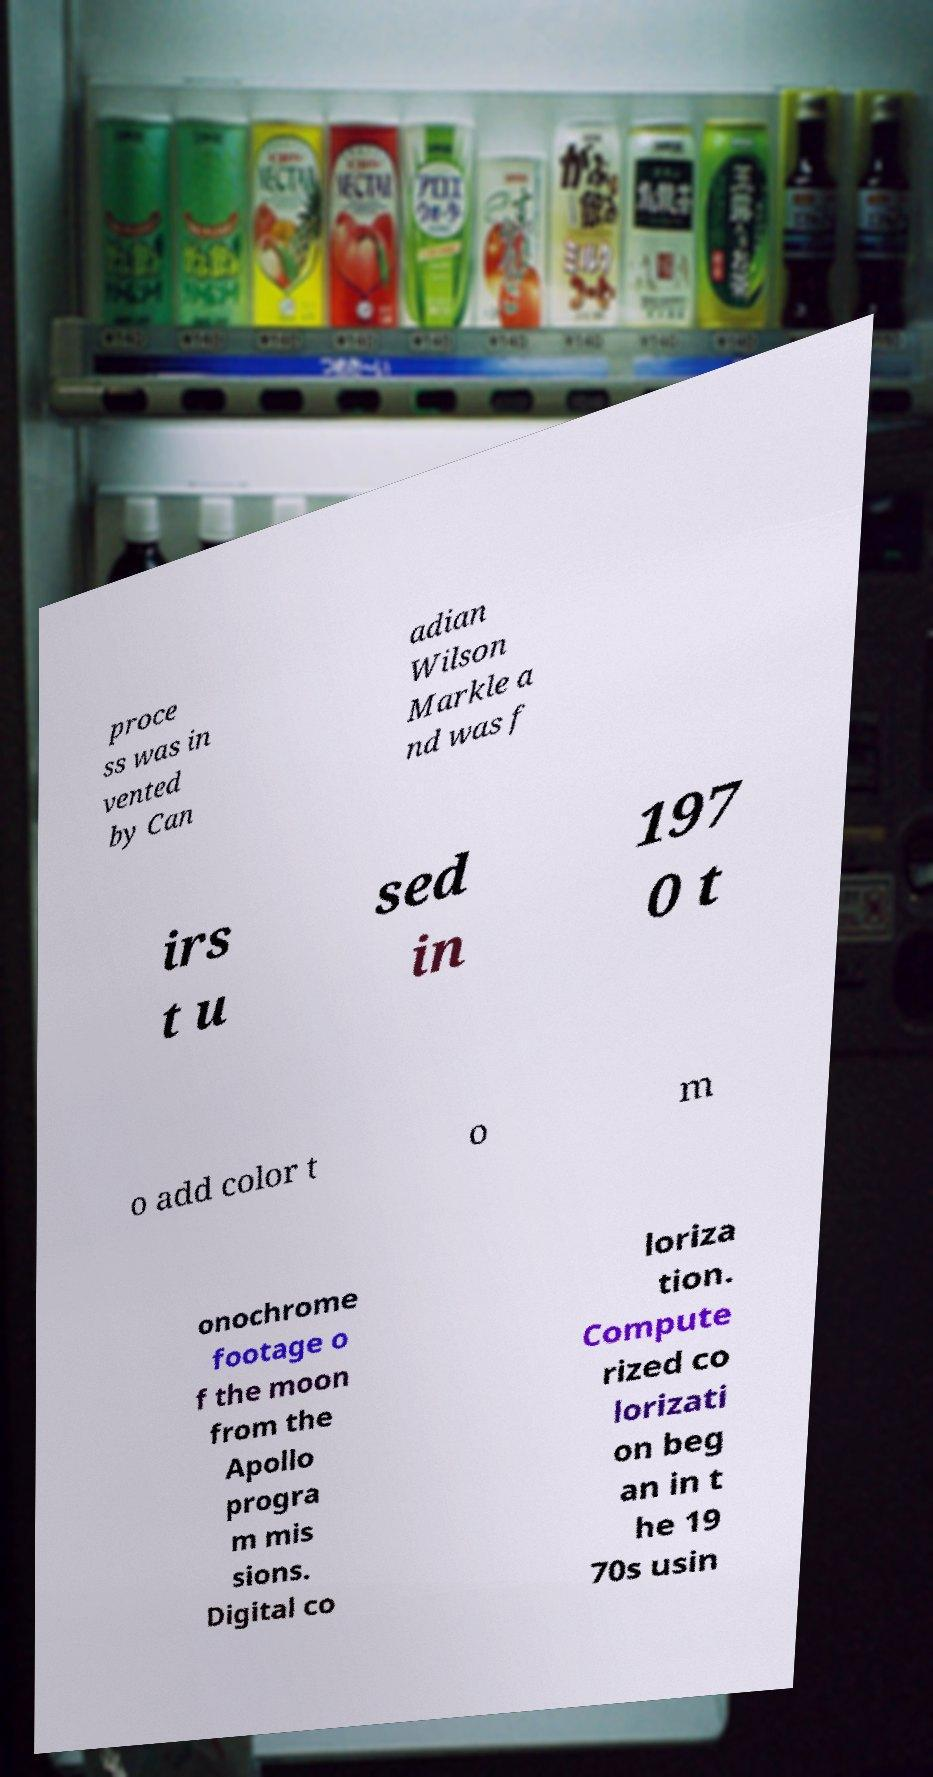Please read and relay the text visible in this image. What does it say? proce ss was in vented by Can adian Wilson Markle a nd was f irs t u sed in 197 0 t o add color t o m onochrome footage o f the moon from the Apollo progra m mis sions. Digital co loriza tion. Compute rized co lorizati on beg an in t he 19 70s usin 